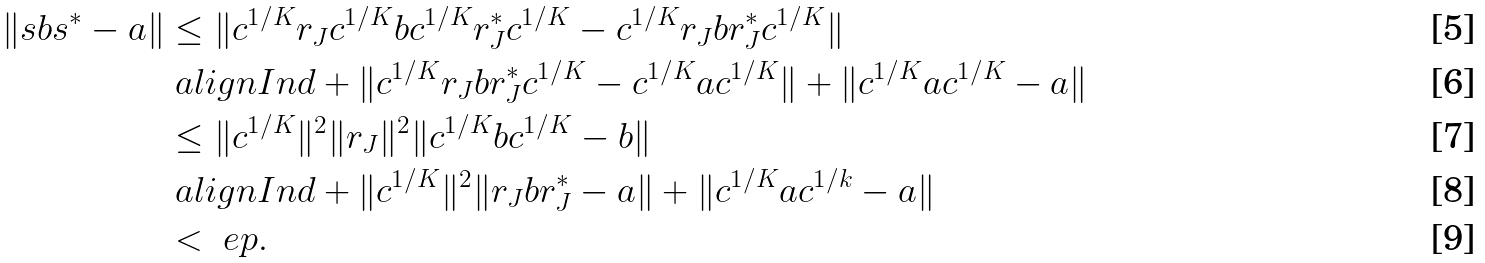<formula> <loc_0><loc_0><loc_500><loc_500>\| s b s ^ { * } - a \| & \leq \| c ^ { 1 / K } r _ { J } c ^ { 1 / K } b c ^ { 1 / K } r _ { J } ^ { * } c ^ { 1 / K } - c ^ { 1 / K } r _ { J } b r _ { J } ^ { * } c ^ { 1 / K } \| \\ & \ a l i g n I n d + \| c ^ { 1 / K } r _ { J } b r _ { J } ^ { * } c ^ { 1 / K } - c ^ { 1 / K } a c ^ { 1 / K } \| + \| c ^ { 1 / K } a c ^ { 1 / K } - a \| \\ & \leq \| c ^ { 1 / K } \| ^ { 2 } \| r _ { J } \| ^ { 2 } \| c ^ { 1 / K } b c ^ { 1 / K } - b \| \\ & \ a l i g n I n d + \| c ^ { 1 / K } \| ^ { 2 } \| r _ { J } b r _ { J } ^ { * } - a \| + \| c ^ { 1 / K } a c ^ { 1 / k } - a \| \\ & < \ e p .</formula> 